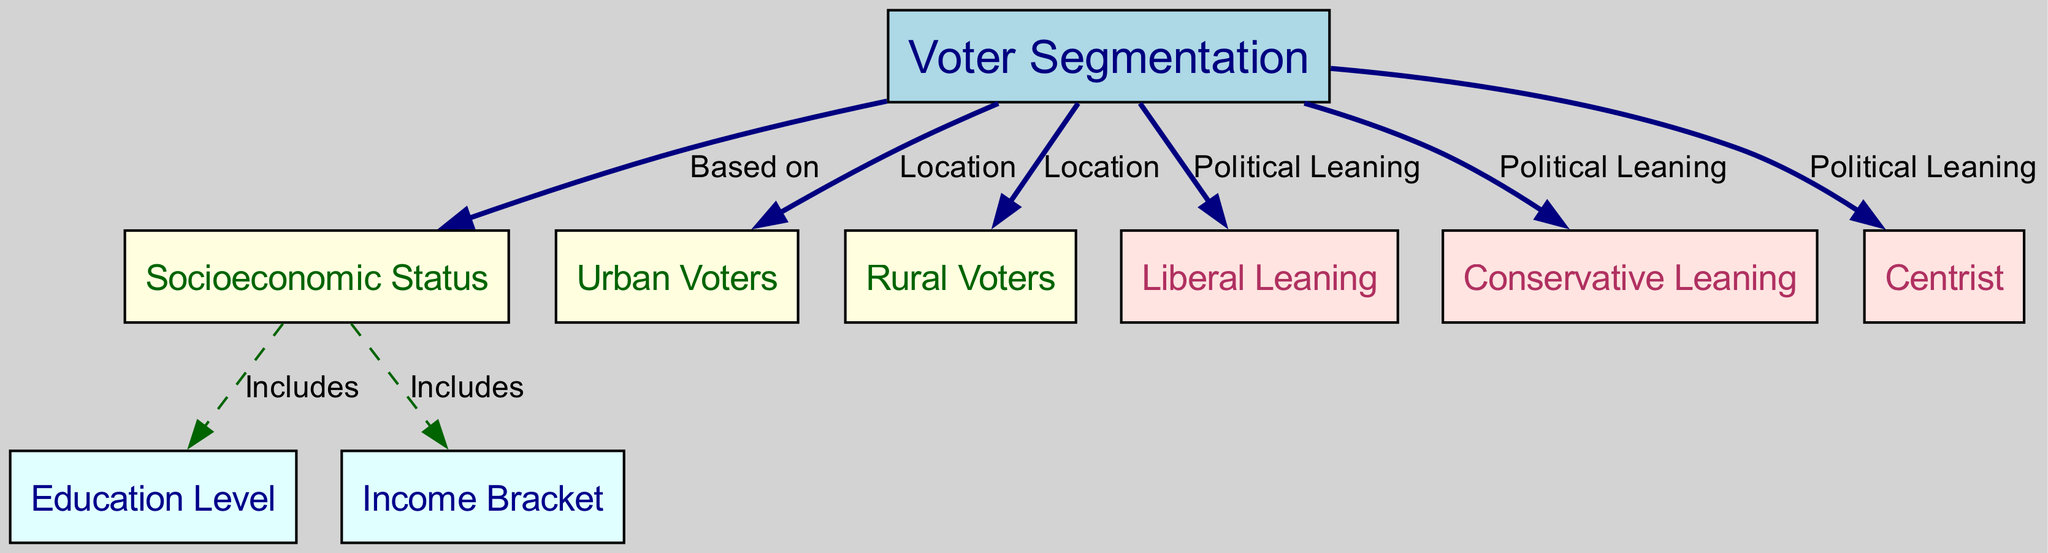What is the root node of this diagram? The root node of the diagram is labeled "Voter Segmentation." It serves as the starting point and encompasses the overall theme of the diagram.
Answer: Voter Segmentation How many nodes are there in the diagram? By counting each unique node listed in the data, there are a total of 9 nodes present in the diagram, including the root and various demographic factors.
Answer: 9 What type of voters is associated with "Urban"? The "Urban Voters" node is directly connected to the root node, indicating that it is categorized under the type of voters by location.
Answer: Urban Voters Which nodes are included under "Socioeconomic Status"? The nodes that fall under "Socioeconomic Status" include "Education Level" and "Income Bracket" as indicated by the edges connecting them to "Socioeconomic Status."
Answer: Education Level, Income Bracket What color is used for nodes that represent "Political Leaning"? The nodes that represent "Political Leaning," such as "Liberal Leaning," "Conservative Leaning," and "Centrist," are styled with a fill color of misty rose as shown by the color attributes defined for those nodes.
Answer: Misty Rose How is "Income Bracket" related to "Socioeconomic Status"? "Income Bracket" is directly connected to "Socioeconomic Status" with a dashed edge labeled "Includes," indicating it is a component of socioeconomic factors.
Answer: Includes Are there more rural voters or urban voters in the diagram? The diagram features a node for "Urban Voters" and a node for "Rural Voters," but it does not provide numerical data on the relative size of these groups; thus, we can only observe that both categories exist equally but not quantitatively.
Answer: Equal What does the edge from "Ses" to "Education" signify? The edge from "Socioeconomic Status" to "Education Level" signifies that education is one of the factors included in defining a person's socioeconomic status, as indicated by the labeled connection.
Answer: Includes Which voter segments fall under conservative leaning? The voter segments that fall under conservative leaning are identified in the corresponding node labeled "Conservative Leaning," showing that it represents a distinct voting group based on political orientation.
Answer: Conservative Leaning 